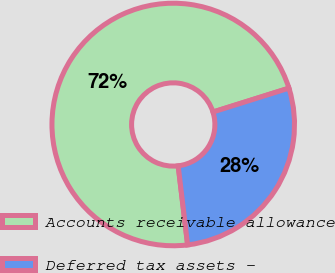Convert chart. <chart><loc_0><loc_0><loc_500><loc_500><pie_chart><fcel>Accounts receivable allowance<fcel>Deferred tax assets -<nl><fcel>72.05%<fcel>27.95%<nl></chart> 